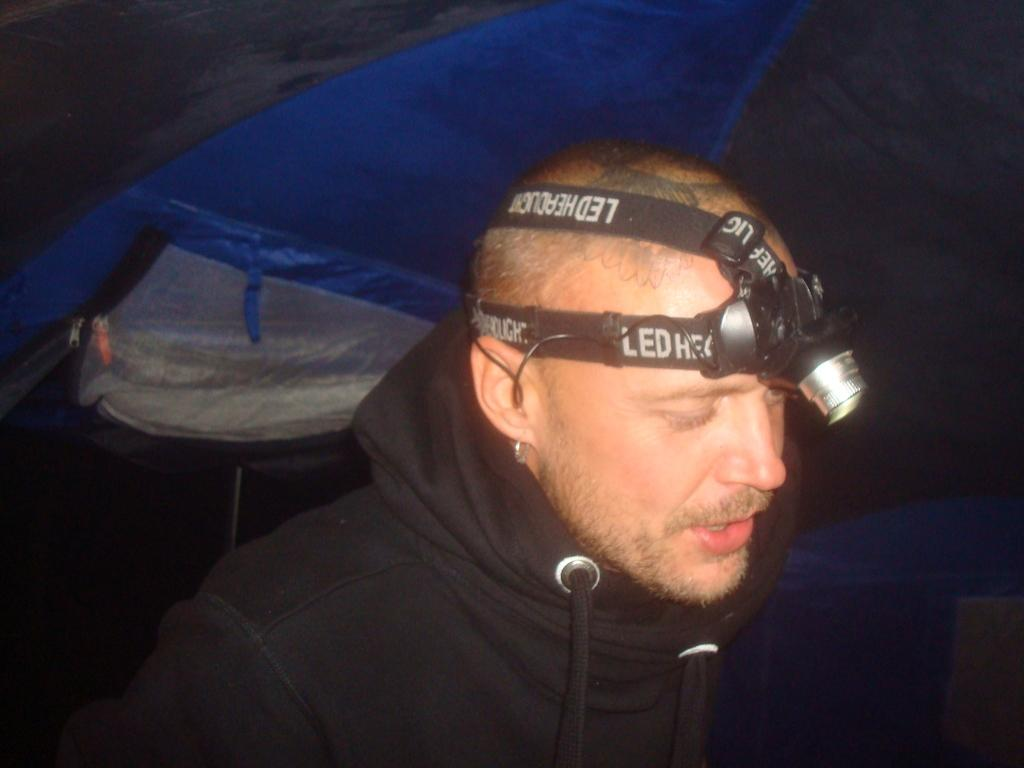What is the main subject of the image? There is a man in the image. What is on the man's head in the image? There appears to be a light on the man's head. Can you describe the background of the image? There might be a tent in the background of the image. What type of company does the man represent in the image? There is no indication in the image that the man represents any company. Is there a party happening in the image? There is no indication in the image that a party is taking place. 